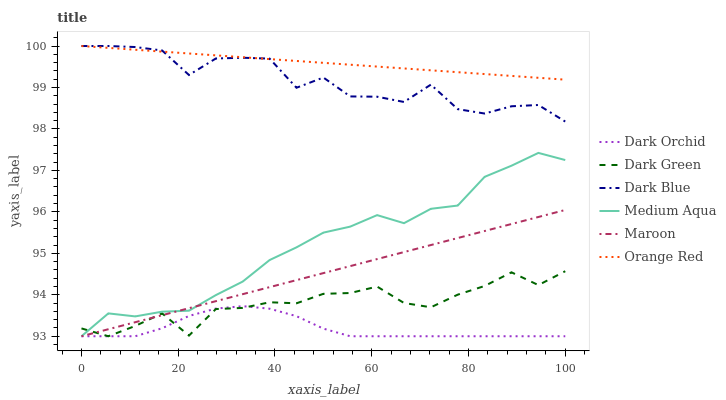Does Dark Orchid have the minimum area under the curve?
Answer yes or no. Yes. Does Orange Red have the maximum area under the curve?
Answer yes or no. Yes. Does Dark Blue have the minimum area under the curve?
Answer yes or no. No. Does Dark Blue have the maximum area under the curve?
Answer yes or no. No. Is Maroon the smoothest?
Answer yes or no. Yes. Is Dark Blue the roughest?
Answer yes or no. Yes. Is Medium Aqua the smoothest?
Answer yes or no. No. Is Medium Aqua the roughest?
Answer yes or no. No. Does Maroon have the lowest value?
Answer yes or no. Yes. Does Dark Blue have the lowest value?
Answer yes or no. No. Does Orange Red have the highest value?
Answer yes or no. Yes. Does Medium Aqua have the highest value?
Answer yes or no. No. Is Dark Orchid less than Dark Blue?
Answer yes or no. Yes. Is Orange Red greater than Maroon?
Answer yes or no. Yes. Does Medium Aqua intersect Maroon?
Answer yes or no. Yes. Is Medium Aqua less than Maroon?
Answer yes or no. No. Is Medium Aqua greater than Maroon?
Answer yes or no. No. Does Dark Orchid intersect Dark Blue?
Answer yes or no. No. 